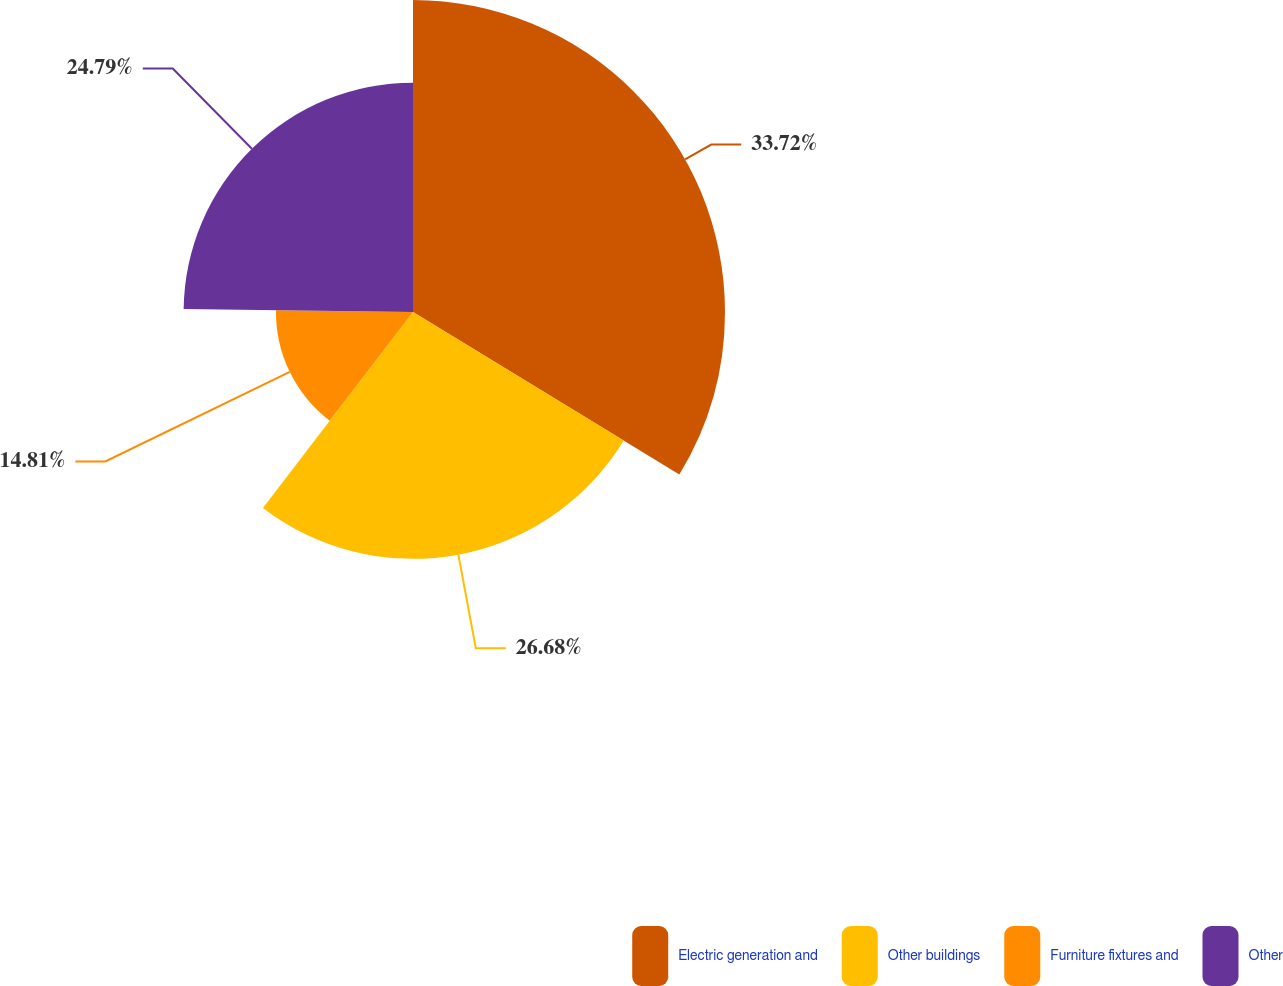Convert chart. <chart><loc_0><loc_0><loc_500><loc_500><pie_chart><fcel>Electric generation and<fcel>Other buildings<fcel>Furniture fixtures and<fcel>Other<nl><fcel>33.72%<fcel>26.68%<fcel>14.81%<fcel>24.79%<nl></chart> 